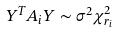Convert formula to latex. <formula><loc_0><loc_0><loc_500><loc_500>Y ^ { T } A _ { i } Y \sim \sigma ^ { 2 } \chi _ { r _ { i } } ^ { 2 }</formula> 